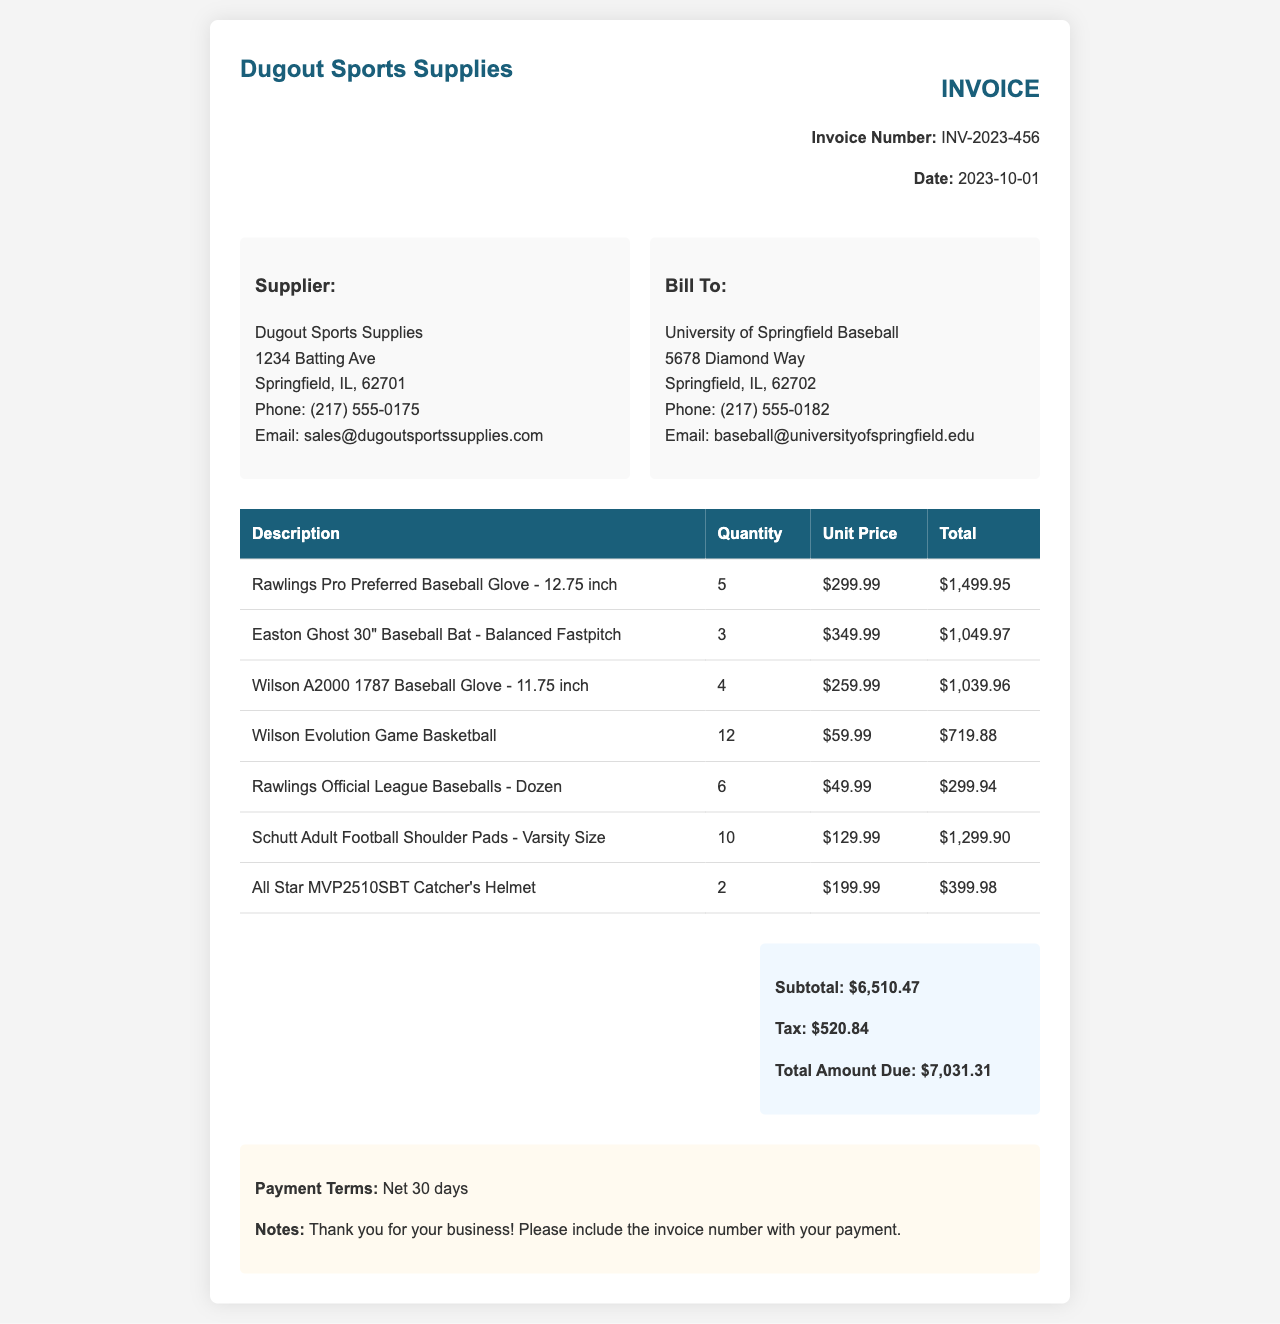What is the invoice number? The invoice number is listed in the invoice details section as INV-2023-456.
Answer: INV-2023-456 What is the date of the invoice? The date appears in the invoice details section, showing when the invoice was issued.
Answer: 2023-10-01 How many Rawlings Pro Preferred Baseball Gloves were purchased? The quantity is listed next to the description of the Rawlings Pro Preferred Baseball Glove.
Answer: 5 What is the subtotal amount? The subtotal is calculated from the total of the individual items before any tax is applied.
Answer: $6,510.47 What is the total amount due? The total amount due combines the subtotal and tax, as outlined in the total section.
Answer: $7,031.31 Who is the supplier? The supplier's name and contact details are provided in the address section of the invoice.
Answer: Dugout Sports Supplies What is the unit price for the Easton Ghost Baseball Bat? The unit price is listed in the invoice table alongside the description of the bat.
Answer: $349.99 How many units of Wilson A2000 1787 Baseball Gloves were ordered? The quantity for the Wilson A2000 1787 Baseball Glove is specified in the invoice table.
Answer: 4 What are the payment terms? The payment terms are specified in the notes section of the invoice.
Answer: Net 30 days 